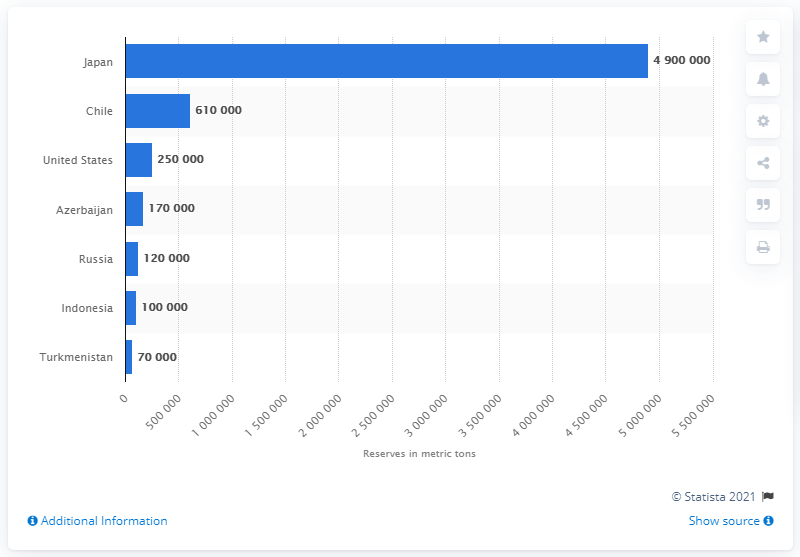Identify some key points in this picture. Japan has approximately 4.9 million metric tons of iodine reserves. 